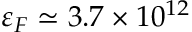<formula> <loc_0><loc_0><loc_500><loc_500>\varepsilon _ { F } \simeq 3 . 7 \times 1 0 ^ { 1 2 }</formula> 